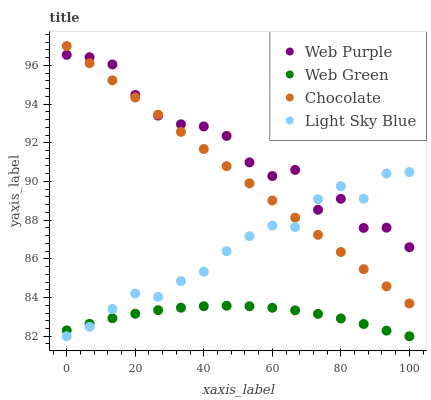Does Web Green have the minimum area under the curve?
Answer yes or no. Yes. Does Web Purple have the maximum area under the curve?
Answer yes or no. Yes. Does Light Sky Blue have the minimum area under the curve?
Answer yes or no. No. Does Light Sky Blue have the maximum area under the curve?
Answer yes or no. No. Is Chocolate the smoothest?
Answer yes or no. Yes. Is Web Purple the roughest?
Answer yes or no. Yes. Is Light Sky Blue the smoothest?
Answer yes or no. No. Is Light Sky Blue the roughest?
Answer yes or no. No. Does Light Sky Blue have the lowest value?
Answer yes or no. Yes. Does Chocolate have the lowest value?
Answer yes or no. No. Does Chocolate have the highest value?
Answer yes or no. Yes. Does Light Sky Blue have the highest value?
Answer yes or no. No. Is Web Green less than Web Purple?
Answer yes or no. Yes. Is Chocolate greater than Web Green?
Answer yes or no. Yes. Does Chocolate intersect Web Purple?
Answer yes or no. Yes. Is Chocolate less than Web Purple?
Answer yes or no. No. Is Chocolate greater than Web Purple?
Answer yes or no. No. Does Web Green intersect Web Purple?
Answer yes or no. No. 